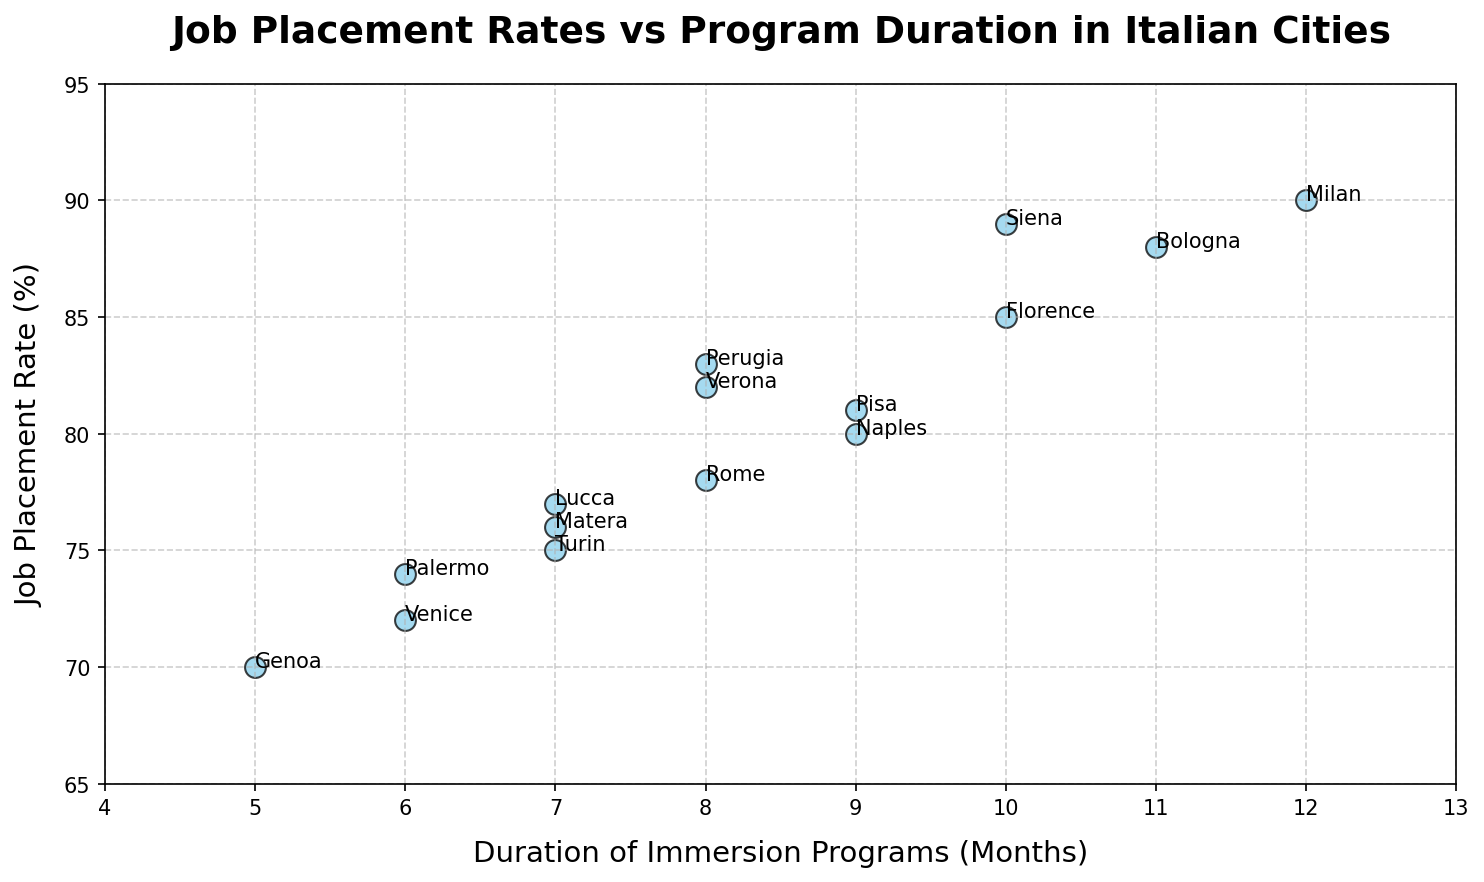Which city has the highest job placement rate? Florence has a job placement rate of 85%, Rome has 78%, Milan has 90%, Venice has 72%, Naples has 80%, Turin has 75%, Bologna has 88%, Genoa has 70%, Verona has 82%, Siena has 89%, Lucca has 77%, Palermo has 74%, Pisa has 81%, Perugia has 83%, Matera has 76%. Milan has the highest job placement rate of 90%.
Answer: Milan Which city has the shortest duration of immersion program? Florence has 10 months, Rome has 8 months, Milan has 12 months, Venice has 6 months, Naples has 9 months, Turin has 7 months, Bologna has 11 months, Genoa has 5 months, Verona has 8 months, Siena has 10 months, Lucca has 7 months, Palermo has 6 months, Pisa has 9 months, Perugia has 8 months, Matera has 7 months. Genoa has the shortest duration of 5 months.
Answer: Genoa What is the duration of the immersion program in Siena? Look at the point labeled Siena on the plot; it is positioned at a duration of 10 months on the x-axis and 89% on the y-axis. Thus, Siena has a duration of 10 months.
Answer: 10 months Which city has a job placement rate closest to 80%? Examine the points around the 80% job placement rate on the y-axis: Naples is at 80%, Lucca is at 77%, Pisa is at 81%, Perugia is at 83%, Matera is at 76%, and Turin is at 75%. Naples has a job placement rate exactly at 80%.
Answer: Naples Which city with a duration of 6 months has a higher job placement rate? Examine the points with a duration of 6 months on the x-axis: Venice is at 72% and Palermo is at 74%. Palermo has a higher job placement rate of 74% compared to Venice's 72%.
Answer: Palermo What are the average job placement rates for cities with durations of immersion programs 8 months or longer? Cities and job placement rates: Florence (85%), Rome (78%), Milan (90%), Venice (72%), Naples (80%), Turin (75%), Bologna (88%), Genoa (70%), Verona (82%), Siena (89%), Lucca (77%), Palermo (74%), Pisa (81%), Perugia (83%), Matera (76%). Filter cities with durations of 8 months or longer: Florence (10, 85), Rome (8, 78), Milan (12, 90), Naples (9, 80), Bologna (11, 88), Verona (8, 82), Siena (10, 89), Pisa (9, 81), Perugia (8, 83). Sum job placement rates: 85 + 78 + 90 + 80 + 88 + 82 + 89 + 81 + 83 = 756. Number of cities: 9. Average = 756 / 9 = 84%.
Answer: 84% Which city has a duration of 7 months and what is its job placement rate? Examine the points at a duration of 7 months on the x-axis: Turin is at 7 months with a 75% job placement rate, Lucca is at 7 months with a 77% job placement rate, Matera is at 7 months with a 76% job placement rate.
Answer: Turin (75%), Lucca (77%), Matera (76%) Is there a trend between program duration and job placement rates? Inspecting the plot as a whole, there isn't a clear, strong trend between program duration and job placement rates as the points are scattered in different directions, suggesting variability.
Answer: No clear trend 